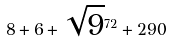Convert formula to latex. <formula><loc_0><loc_0><loc_500><loc_500>8 + 6 + \sqrt { 9 } ^ { 7 2 } + 2 9 0</formula> 